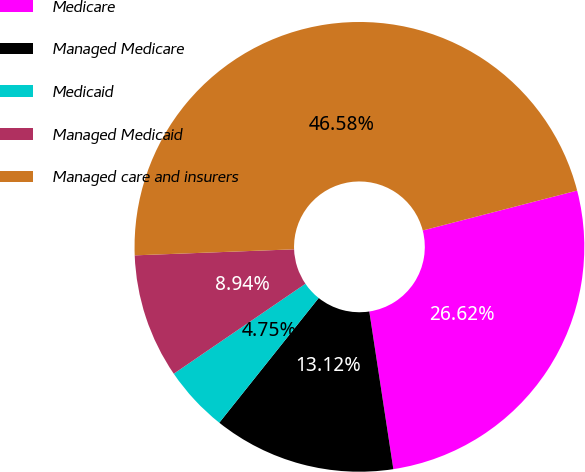Convert chart to OTSL. <chart><loc_0><loc_0><loc_500><loc_500><pie_chart><fcel>Medicare<fcel>Managed Medicare<fcel>Medicaid<fcel>Managed Medicaid<fcel>Managed care and insurers<nl><fcel>26.62%<fcel>13.12%<fcel>4.75%<fcel>8.94%<fcel>46.58%<nl></chart> 